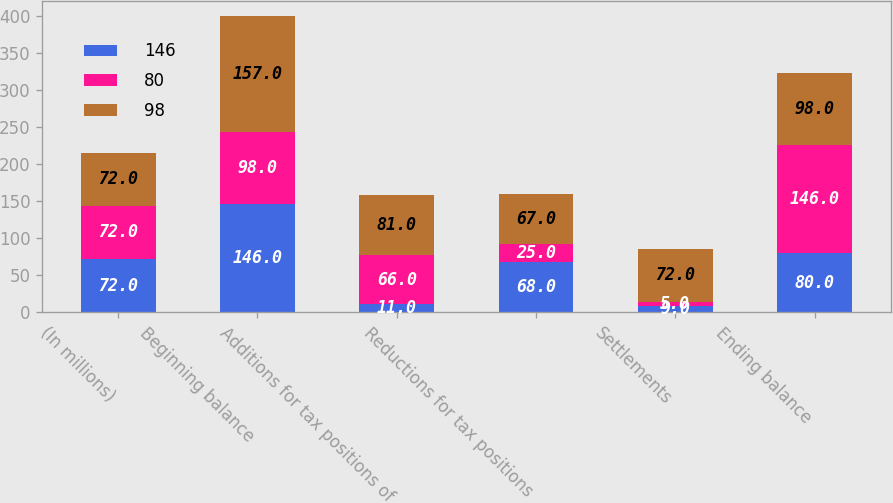<chart> <loc_0><loc_0><loc_500><loc_500><stacked_bar_chart><ecel><fcel>(In millions)<fcel>Beginning balance<fcel>Additions for tax positions of<fcel>Reductions for tax positions<fcel>Settlements<fcel>Ending balance<nl><fcel>146<fcel>72<fcel>146<fcel>11<fcel>68<fcel>9<fcel>80<nl><fcel>80<fcel>72<fcel>98<fcel>66<fcel>25<fcel>5<fcel>146<nl><fcel>98<fcel>72<fcel>157<fcel>81<fcel>67<fcel>72<fcel>98<nl></chart> 